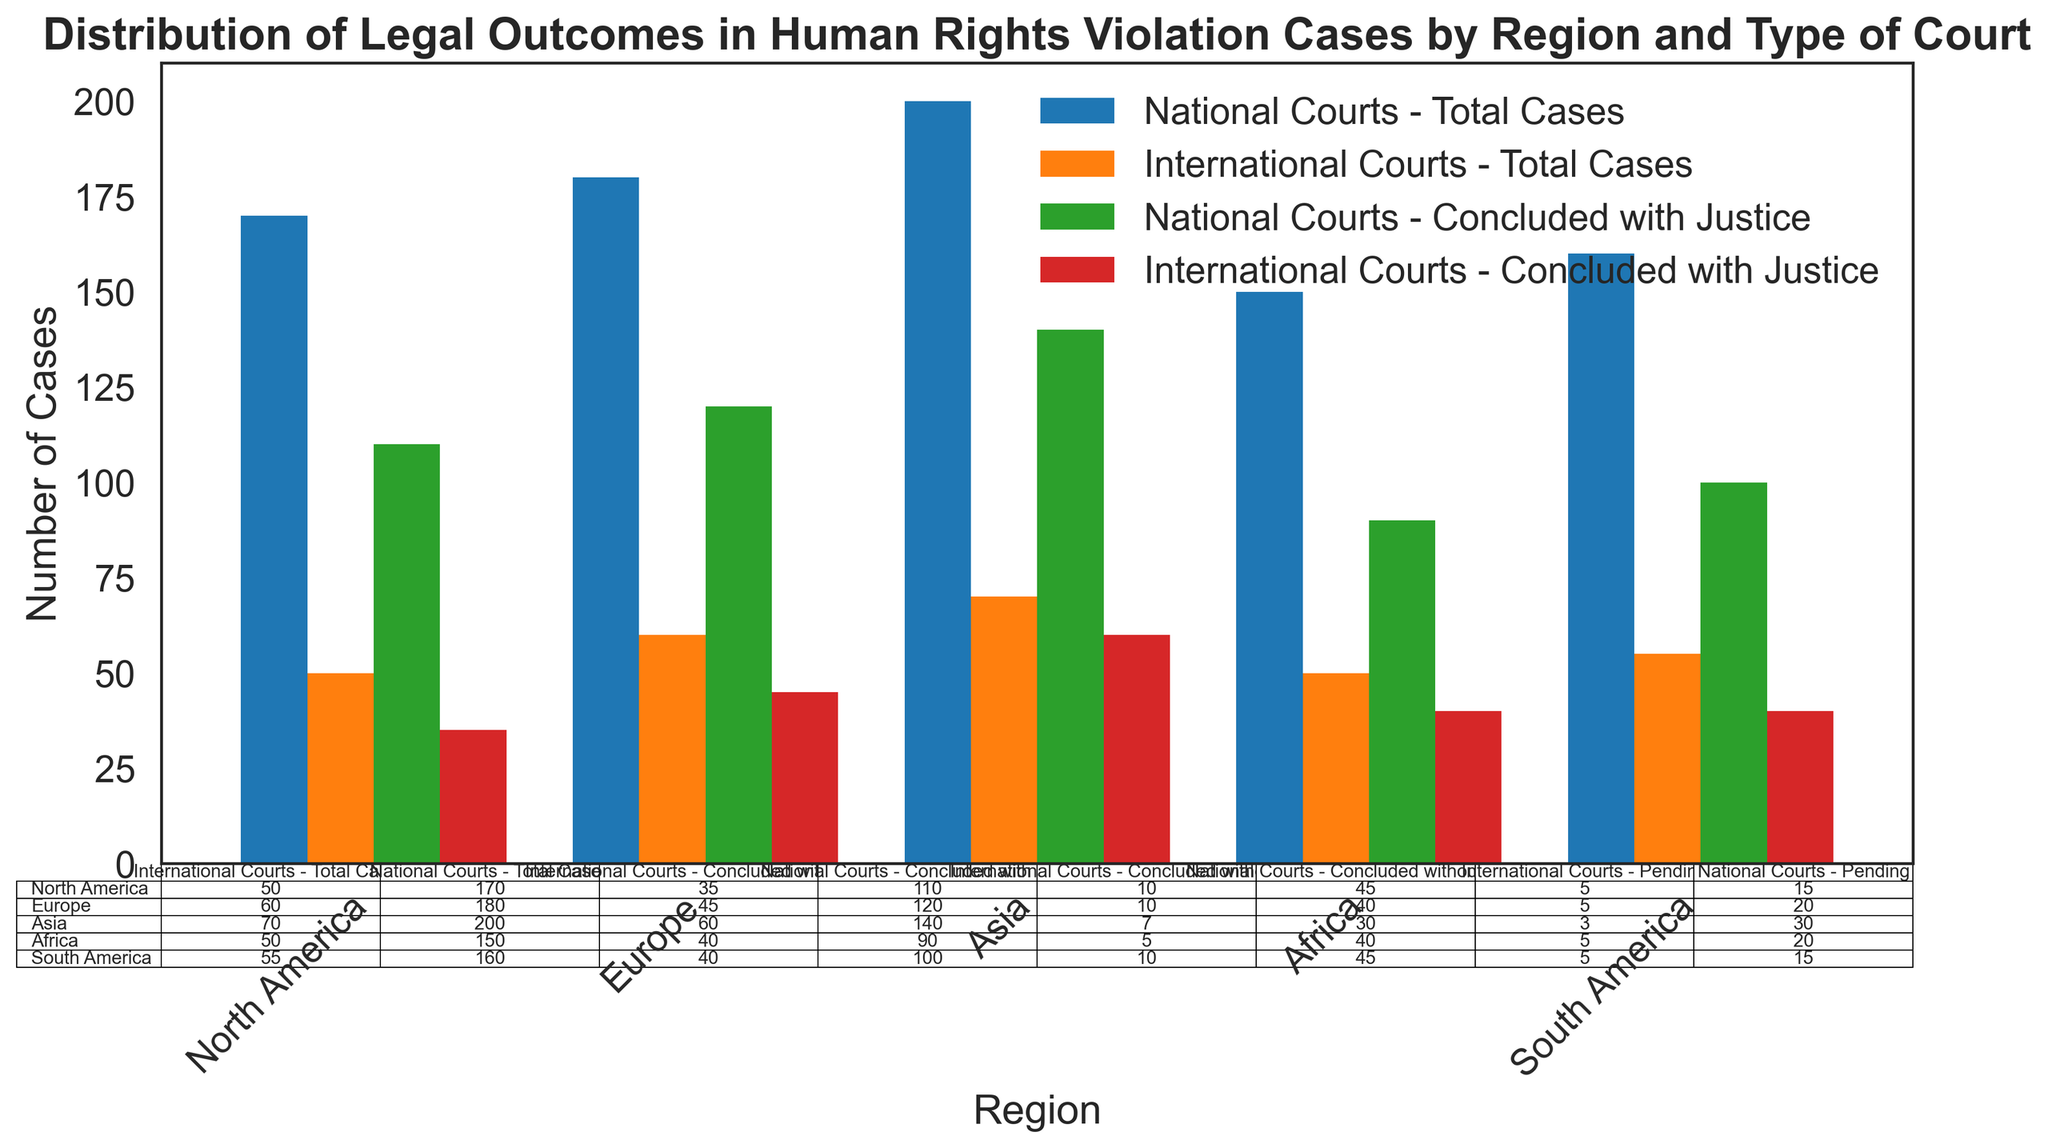Which region has the highest number of total cases in national courts? Look at the bars for 'Total Cases - National Courts' across regions. The bar for Europe appears the tallest.
Answer: Europe Which type of court has a higher number of cases concluded with justice in Asia? Compare the 'Concluded with Justice - National Courts' and 'Concluded with Justice - International Courts' bars for Asia. The bar representing national courts is higher.
Answer: National Courts What is the difference between the number of cases pending in North America for national and international courts? Refer to the table for 'Pending' cases in North America: National Courts have 20 and International Courts have 5. Calculate the difference: 20 - 5.
Answer: 15 Which region has the least number of cases concluded without justice in international courts? Compare the 'Concluded without Justice - International Courts' bars across regions. North America has the smallest value of 5.
Answer: North America Summing up concluded with justice cases, which region has the highest total for national and international courts combined? Add the 'Concluded with Justice - National Courts' and 'Concluded with Justice - International Courts' values for each region. Sum for Europe is (140 + 60) = 200, which is the highest.
Answer: Europe How many total cases did North America have across both national and international courts? Add the 'Total Cases - National Courts' and 'Total Cases - International Courts' for North America: 150 + 50.
Answer: 200 Is the percentage of cases concluded with justice higher in international courts or national courts for Africa? Calculate the percentage for both court types in Africa. National Courts: 110/170 ≈ 64.7%. International Courts: 35/50 = 70%. Compare these percentages.
Answer: International Courts Compare the number of pending cases in Europe between national and international courts. Which type has fewer pending cases? Check the table for 'Pending' cases in Europe. National Courts have 30, International Courts have 3. 3 is less than 30.
Answer: International Courts What is the total number of concluded without justice cases in South America for both types of courts? Sum the 'Concluded without Justice' cases for both national and international courts in South America: 45 + 10.
Answer: 55 In which region do national courts handle more cases than international courts by the largest margin? Calculate the difference between 'Total Cases - National Courts' and 'Total Cases - International Courts' for each region. North America: 150-50 = 100, Europe: 200-70 = 130, Asia: 180-60 = 120, Africa: 170-50 = 120, South America: 160-55 = 105. Europe has the largest margin of 130.
Answer: Europe 